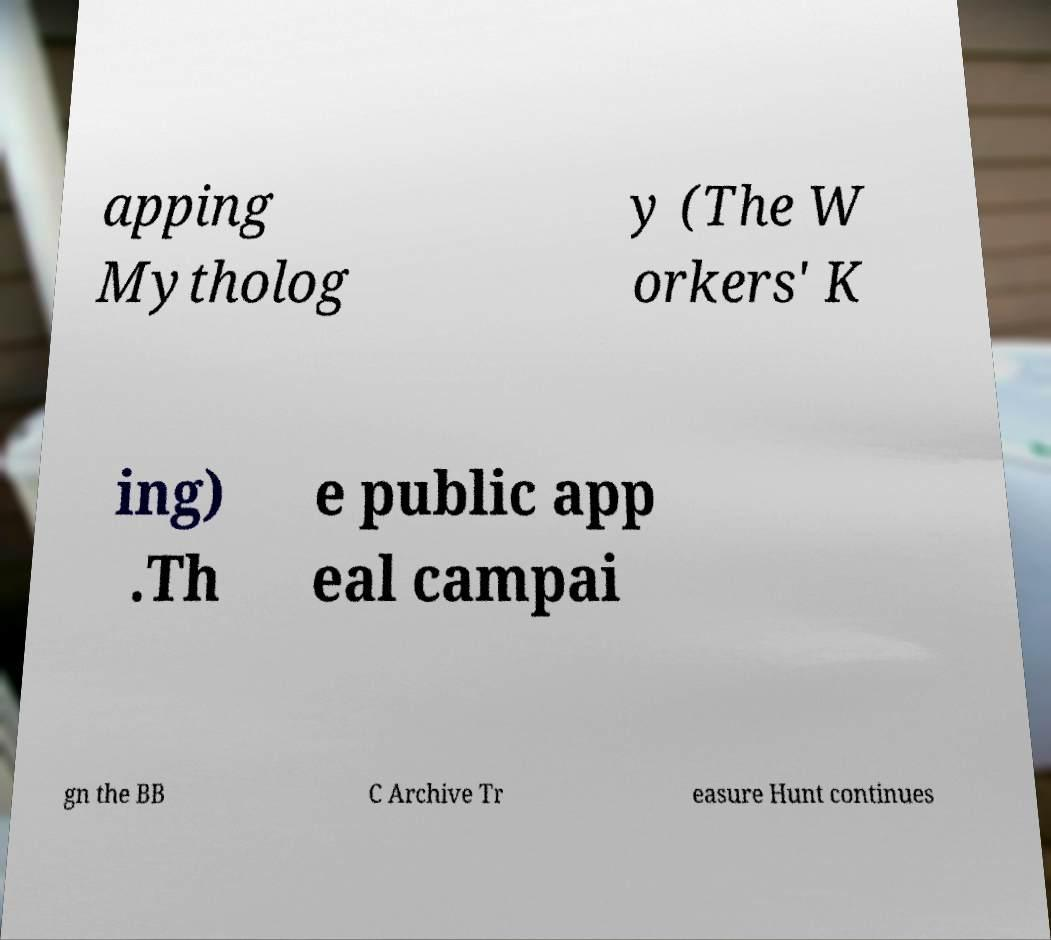Could you assist in decoding the text presented in this image and type it out clearly? apping Mytholog y (The W orkers' K ing) .Th e public app eal campai gn the BB C Archive Tr easure Hunt continues 